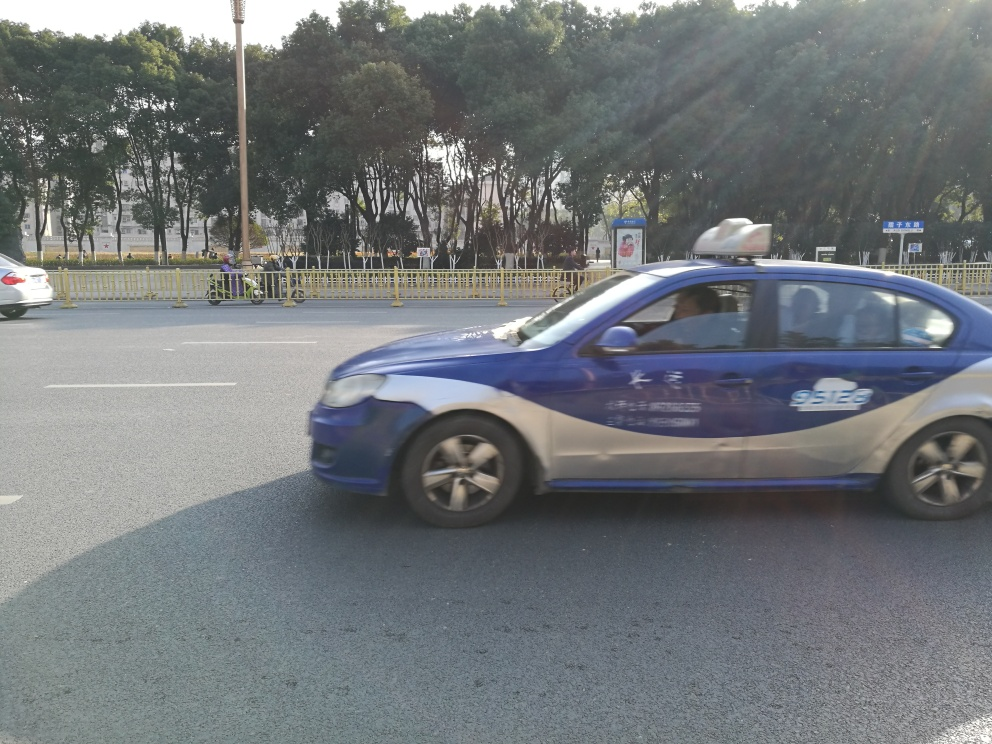Are there any pedestrians or other significant details in the scene? There are no pedestrians visible in the immediate vicinity of the street; however, there is a pedestrian barrier and some people who appear to be sitting or standing beyond the fence, indicating a separated walkway or resting area. 